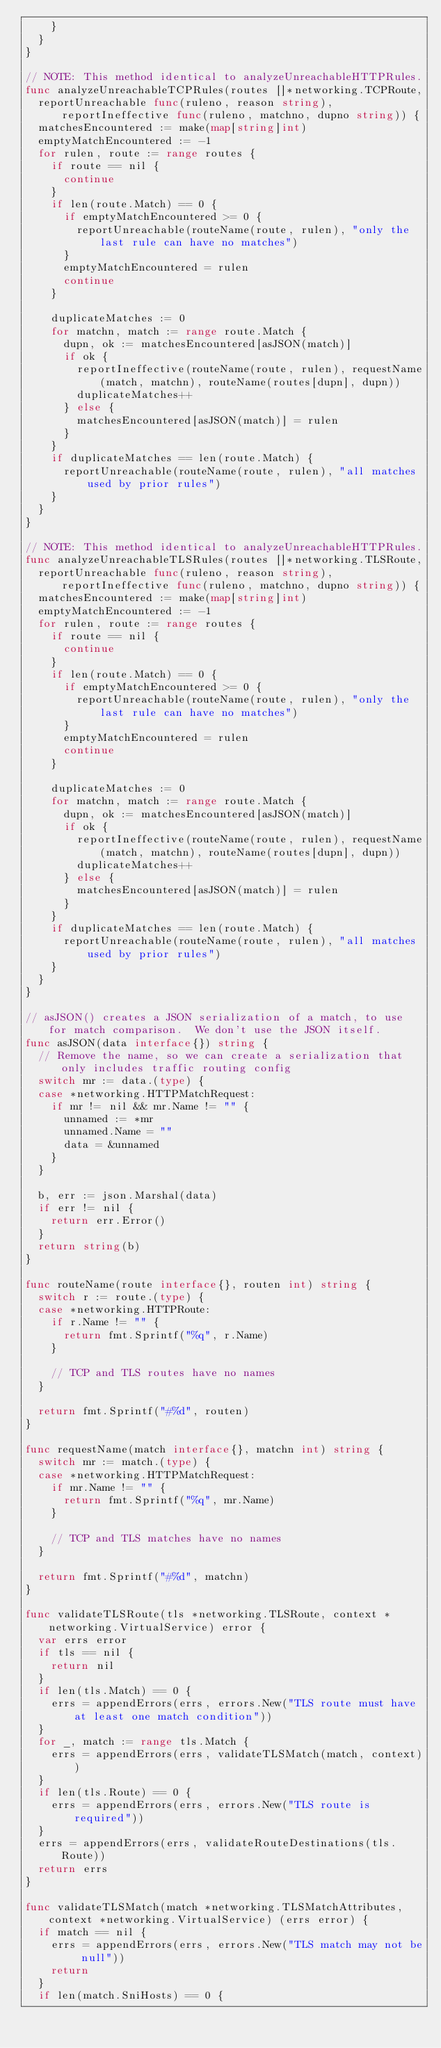Convert code to text. <code><loc_0><loc_0><loc_500><loc_500><_Go_>		}
	}
}

// NOTE: This method identical to analyzeUnreachableHTTPRules.
func analyzeUnreachableTCPRules(routes []*networking.TCPRoute,
	reportUnreachable func(ruleno, reason string), reportIneffective func(ruleno, matchno, dupno string)) {
	matchesEncountered := make(map[string]int)
	emptyMatchEncountered := -1
	for rulen, route := range routes {
		if route == nil {
			continue
		}
		if len(route.Match) == 0 {
			if emptyMatchEncountered >= 0 {
				reportUnreachable(routeName(route, rulen), "only the last rule can have no matches")
			}
			emptyMatchEncountered = rulen
			continue
		}

		duplicateMatches := 0
		for matchn, match := range route.Match {
			dupn, ok := matchesEncountered[asJSON(match)]
			if ok {
				reportIneffective(routeName(route, rulen), requestName(match, matchn), routeName(routes[dupn], dupn))
				duplicateMatches++
			} else {
				matchesEncountered[asJSON(match)] = rulen
			}
		}
		if duplicateMatches == len(route.Match) {
			reportUnreachable(routeName(route, rulen), "all matches used by prior rules")
		}
	}
}

// NOTE: This method identical to analyzeUnreachableHTTPRules.
func analyzeUnreachableTLSRules(routes []*networking.TLSRoute,
	reportUnreachable func(ruleno, reason string), reportIneffective func(ruleno, matchno, dupno string)) {
	matchesEncountered := make(map[string]int)
	emptyMatchEncountered := -1
	for rulen, route := range routes {
		if route == nil {
			continue
		}
		if len(route.Match) == 0 {
			if emptyMatchEncountered >= 0 {
				reportUnreachable(routeName(route, rulen), "only the last rule can have no matches")
			}
			emptyMatchEncountered = rulen
			continue
		}

		duplicateMatches := 0
		for matchn, match := range route.Match {
			dupn, ok := matchesEncountered[asJSON(match)]
			if ok {
				reportIneffective(routeName(route, rulen), requestName(match, matchn), routeName(routes[dupn], dupn))
				duplicateMatches++
			} else {
				matchesEncountered[asJSON(match)] = rulen
			}
		}
		if duplicateMatches == len(route.Match) {
			reportUnreachable(routeName(route, rulen), "all matches used by prior rules")
		}
	}
}

// asJSON() creates a JSON serialization of a match, to use for match comparison.  We don't use the JSON itself.
func asJSON(data interface{}) string {
	// Remove the name, so we can create a serialization that only includes traffic routing config
	switch mr := data.(type) {
	case *networking.HTTPMatchRequest:
		if mr != nil && mr.Name != "" {
			unnamed := *mr
			unnamed.Name = ""
			data = &unnamed
		}
	}

	b, err := json.Marshal(data)
	if err != nil {
		return err.Error()
	}
	return string(b)
}

func routeName(route interface{}, routen int) string {
	switch r := route.(type) {
	case *networking.HTTPRoute:
		if r.Name != "" {
			return fmt.Sprintf("%q", r.Name)
		}

		// TCP and TLS routes have no names
	}

	return fmt.Sprintf("#%d", routen)
}

func requestName(match interface{}, matchn int) string {
	switch mr := match.(type) {
	case *networking.HTTPMatchRequest:
		if mr.Name != "" {
			return fmt.Sprintf("%q", mr.Name)
		}

		// TCP and TLS matches have no names
	}

	return fmt.Sprintf("#%d", matchn)
}

func validateTLSRoute(tls *networking.TLSRoute, context *networking.VirtualService) error {
	var errs error
	if tls == nil {
		return nil
	}
	if len(tls.Match) == 0 {
		errs = appendErrors(errs, errors.New("TLS route must have at least one match condition"))
	}
	for _, match := range tls.Match {
		errs = appendErrors(errs, validateTLSMatch(match, context))
	}
	if len(tls.Route) == 0 {
		errs = appendErrors(errs, errors.New("TLS route is required"))
	}
	errs = appendErrors(errs, validateRouteDestinations(tls.Route))
	return errs
}

func validateTLSMatch(match *networking.TLSMatchAttributes, context *networking.VirtualService) (errs error) {
	if match == nil {
		errs = appendErrors(errs, errors.New("TLS match may not be null"))
		return
	}
	if len(match.SniHosts) == 0 {</code> 